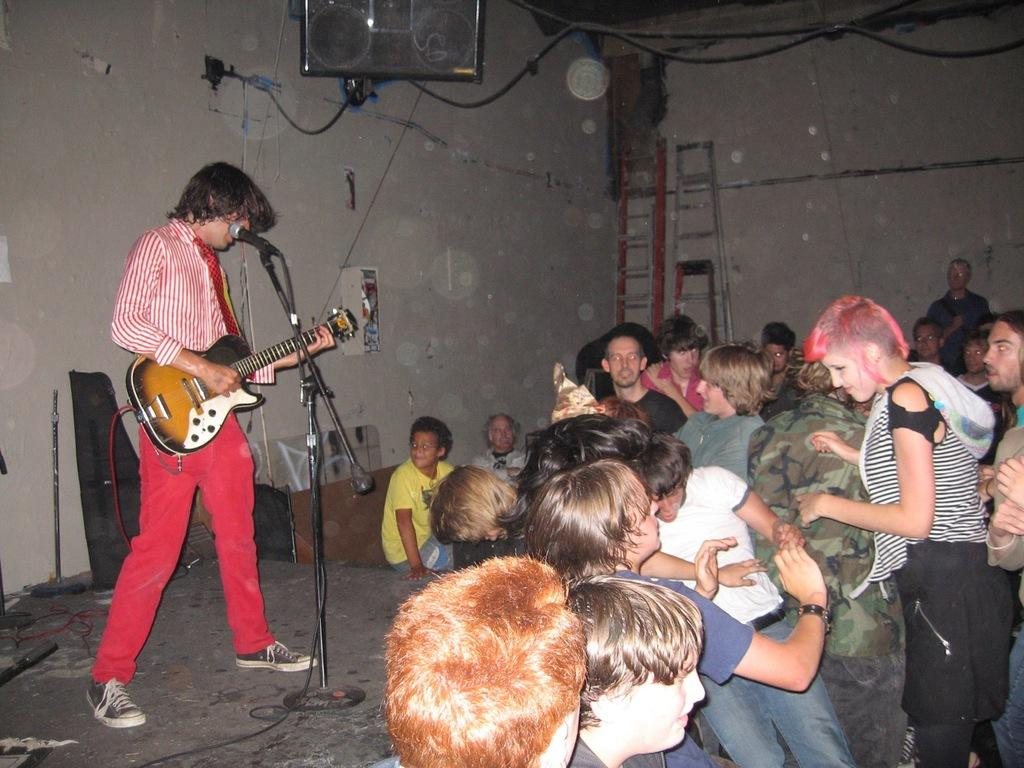What are the people in the image doing? There are people standing and sitting in the image. What activity is one person engaged in? A person is playing a guitar. What equipment is present for amplifying sound? There is a microphone with a stand in the image. What can be seen in the background of the image? There is a wall, ladders, and posters in the background of the image. How many planes can be seen flying over the crowd in the image? There are no planes or crowds present in the image; it features people standing and sitting, a guitar player, a microphone with a stand, and a background with a wall, ladders, and posters. 